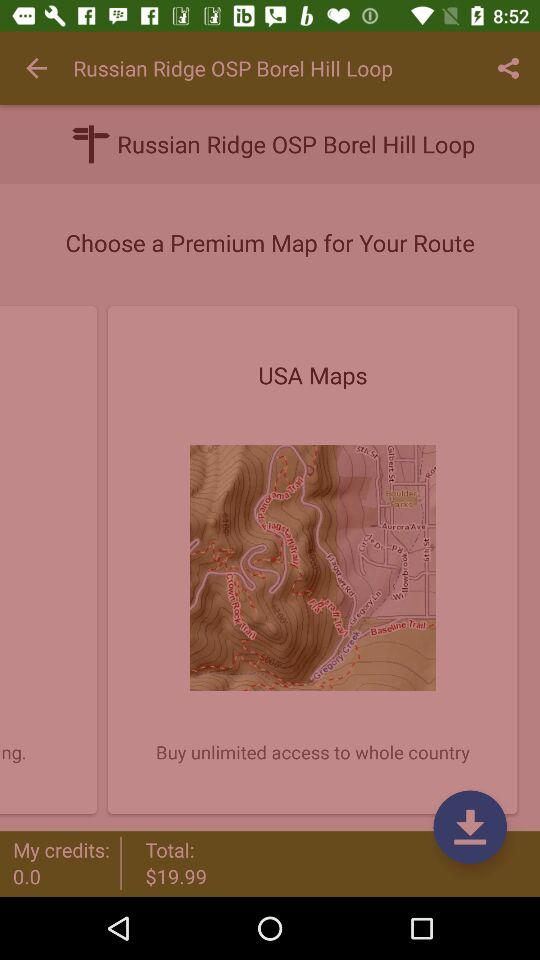How many credits will I have after purchasing the USA map?
Answer the question using a single word or phrase. 0.0 